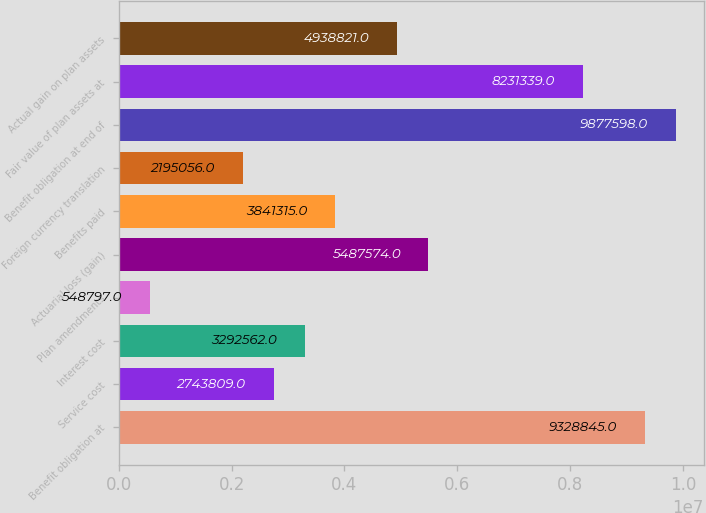Convert chart to OTSL. <chart><loc_0><loc_0><loc_500><loc_500><bar_chart><fcel>Benefit obligation at<fcel>Service cost<fcel>Interest cost<fcel>Plan amendments<fcel>Actuarial loss (gain)<fcel>Benefits paid<fcel>Foreign currency translation<fcel>Benefit obligation at end of<fcel>Fair value of plan assets at<fcel>Actual gain on plan assets<nl><fcel>9.32884e+06<fcel>2.74381e+06<fcel>3.29256e+06<fcel>548797<fcel>5.48757e+06<fcel>3.84132e+06<fcel>2.19506e+06<fcel>9.8776e+06<fcel>8.23134e+06<fcel>4.93882e+06<nl></chart> 